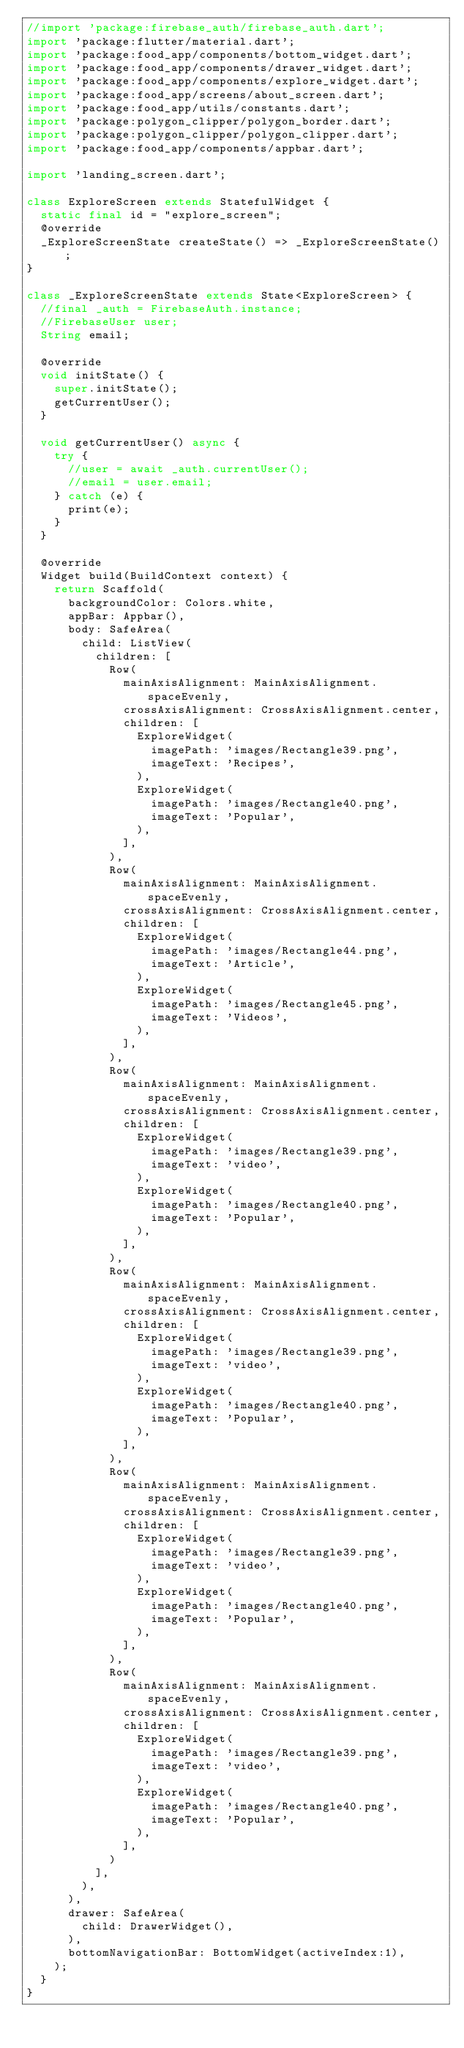Convert code to text. <code><loc_0><loc_0><loc_500><loc_500><_Dart_>//import 'package:firebase_auth/firebase_auth.dart';
import 'package:flutter/material.dart';
import 'package:food_app/components/bottom_widget.dart';
import 'package:food_app/components/drawer_widget.dart';
import 'package:food_app/components/explore_widget.dart';
import 'package:food_app/screens/about_screen.dart';
import 'package:food_app/utils/constants.dart';
import 'package:polygon_clipper/polygon_border.dart';
import 'package:polygon_clipper/polygon_clipper.dart';
import 'package:food_app/components/appbar.dart';

import 'landing_screen.dart';

class ExploreScreen extends StatefulWidget {
  static final id = "explore_screen";
  @override
  _ExploreScreenState createState() => _ExploreScreenState();
}

class _ExploreScreenState extends State<ExploreScreen> {
  //final _auth = FirebaseAuth.instance;
  //FirebaseUser user;
  String email;

  @override
  void initState() {
    super.initState();
    getCurrentUser();
  }

  void getCurrentUser() async {
    try {
      //user = await _auth.currentUser();
      //email = user.email;
    } catch (e) {
      print(e);
    }
  }

  @override
  Widget build(BuildContext context) {
    return Scaffold(
      backgroundColor: Colors.white,
      appBar: Appbar(),
      body: SafeArea(
        child: ListView(
          children: [
            Row(
              mainAxisAlignment: MainAxisAlignment.spaceEvenly,
              crossAxisAlignment: CrossAxisAlignment.center,
              children: [
                ExploreWidget(
                  imagePath: 'images/Rectangle39.png',
                  imageText: 'Recipes',
                ),
                ExploreWidget(
                  imagePath: 'images/Rectangle40.png',
                  imageText: 'Popular',
                ),
              ],
            ),
            Row(
              mainAxisAlignment: MainAxisAlignment.spaceEvenly,
              crossAxisAlignment: CrossAxisAlignment.center,
              children: [
                ExploreWidget(
                  imagePath: 'images/Rectangle44.png',
                  imageText: 'Article',
                ),
                ExploreWidget(
                  imagePath: 'images/Rectangle45.png',
                  imageText: 'Videos',
                ),
              ],
            ),
            Row(
              mainAxisAlignment: MainAxisAlignment.spaceEvenly,
              crossAxisAlignment: CrossAxisAlignment.center,
              children: [
                ExploreWidget(
                  imagePath: 'images/Rectangle39.png',
                  imageText: 'video',
                ),
                ExploreWidget(
                  imagePath: 'images/Rectangle40.png',
                  imageText: 'Popular',
                ),
              ],
            ),
            Row(
              mainAxisAlignment: MainAxisAlignment.spaceEvenly,
              crossAxisAlignment: CrossAxisAlignment.center,
              children: [
                ExploreWidget(
                  imagePath: 'images/Rectangle39.png',
                  imageText: 'video',
                ),
                ExploreWidget(
                  imagePath: 'images/Rectangle40.png',
                  imageText: 'Popular',
                ),
              ],
            ),
            Row(
              mainAxisAlignment: MainAxisAlignment.spaceEvenly,
              crossAxisAlignment: CrossAxisAlignment.center,
              children: [
                ExploreWidget(
                  imagePath: 'images/Rectangle39.png',
                  imageText: 'video',
                ),
                ExploreWidget(
                  imagePath: 'images/Rectangle40.png',
                  imageText: 'Popular',
                ),
              ],
            ),
            Row(
              mainAxisAlignment: MainAxisAlignment.spaceEvenly,
              crossAxisAlignment: CrossAxisAlignment.center,
              children: [
                ExploreWidget(
                  imagePath: 'images/Rectangle39.png',
                  imageText: 'video',
                ),
                ExploreWidget(
                  imagePath: 'images/Rectangle40.png',
                  imageText: 'Popular',
                ),
              ],
            )
          ],
        ),
      ),
      drawer: SafeArea(
        child: DrawerWidget(),
      ),
      bottomNavigationBar: BottomWidget(activeIndex:1),
    );
  }
}
</code> 